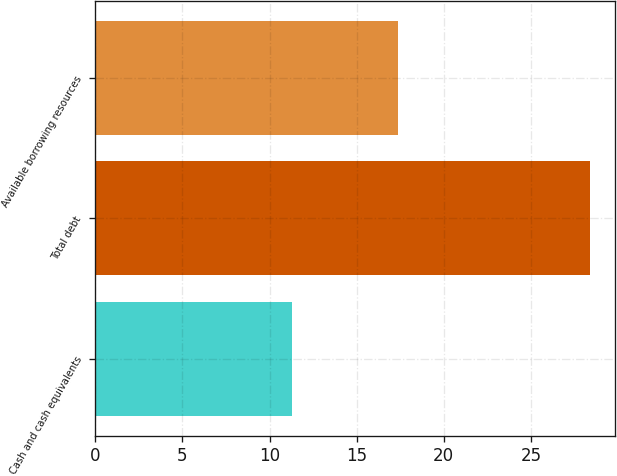Convert chart. <chart><loc_0><loc_0><loc_500><loc_500><bar_chart><fcel>Cash and cash equivalents<fcel>Total debt<fcel>Available borrowing resources<nl><fcel>11.3<fcel>28.4<fcel>17.4<nl></chart> 